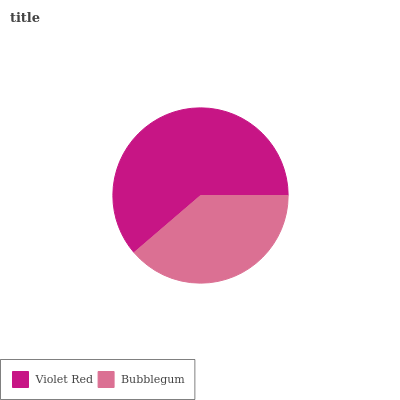Is Bubblegum the minimum?
Answer yes or no. Yes. Is Violet Red the maximum?
Answer yes or no. Yes. Is Bubblegum the maximum?
Answer yes or no. No. Is Violet Red greater than Bubblegum?
Answer yes or no. Yes. Is Bubblegum less than Violet Red?
Answer yes or no. Yes. Is Bubblegum greater than Violet Red?
Answer yes or no. No. Is Violet Red less than Bubblegum?
Answer yes or no. No. Is Violet Red the high median?
Answer yes or no. Yes. Is Bubblegum the low median?
Answer yes or no. Yes. Is Bubblegum the high median?
Answer yes or no. No. Is Violet Red the low median?
Answer yes or no. No. 